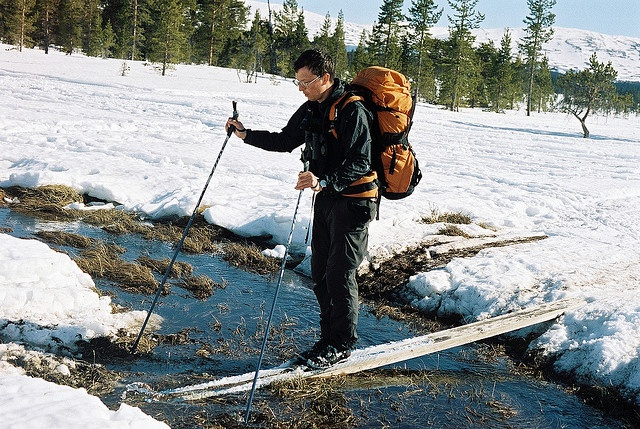Describe the objects in this image and their specific colors. I can see people in olive, black, gray, brown, and darkgray tones, backpack in olive, black, maroon, brown, and tan tones, and skis in olive, lightgray, darkgray, tan, and gray tones in this image. 